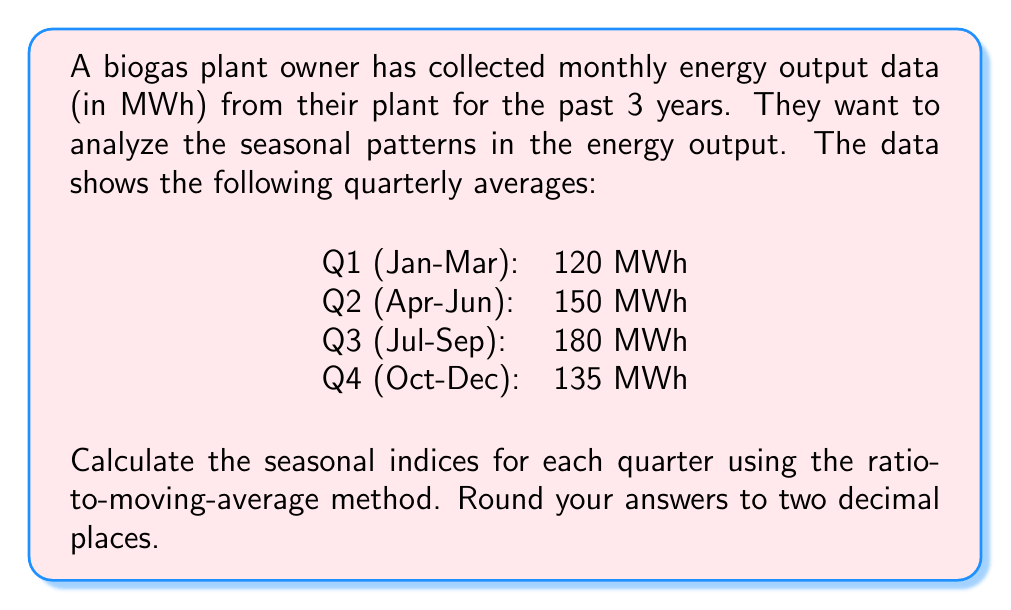Solve this math problem. To calculate the seasonal indices using the ratio-to-moving-average method, we'll follow these steps:

1. Calculate the annual average output:
   $$ \text{Annual Average} = \frac{120 + 150 + 180 + 135}{4} = 146.25 \text{ MWh} $$

2. Calculate the ratio of each quarter's output to the annual average:
   
   Q1: $\frac{120}{146.25} = 0.8205$
   Q2: $\frac{150}{146.25} = 1.0256$
   Q3: $\frac{180}{146.25} = 1.2308$
   Q4: $\frac{135}{146.25} = 0.9231$

3. Normalize the ratios so that they sum to 4 (since we have 4 quarters):
   
   Sum of ratios: $0.8205 + 1.0256 + 1.2308 + 0.9231 = 4$

   The ratios already sum to 4, so no normalization is needed.

4. The seasonal indices are these normalized ratios:

   Q1: $0.8205$
   Q2: $1.0256$
   Q3: $1.2308$
   Q4: $0.9231$

Rounding to two decimal places:

Q1: $0.82$
Q2: $1.03$
Q3: $1.23$
Q4: $0.92$
Answer: The seasonal indices for each quarter, rounded to two decimal places, are:

Q1: 0.82
Q2: 1.03
Q3: 1.23
Q4: 0.92 